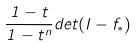Convert formula to latex. <formula><loc_0><loc_0><loc_500><loc_500>\frac { 1 - t } { 1 - t ^ { n } } d e t ( I - f _ { * } )</formula> 